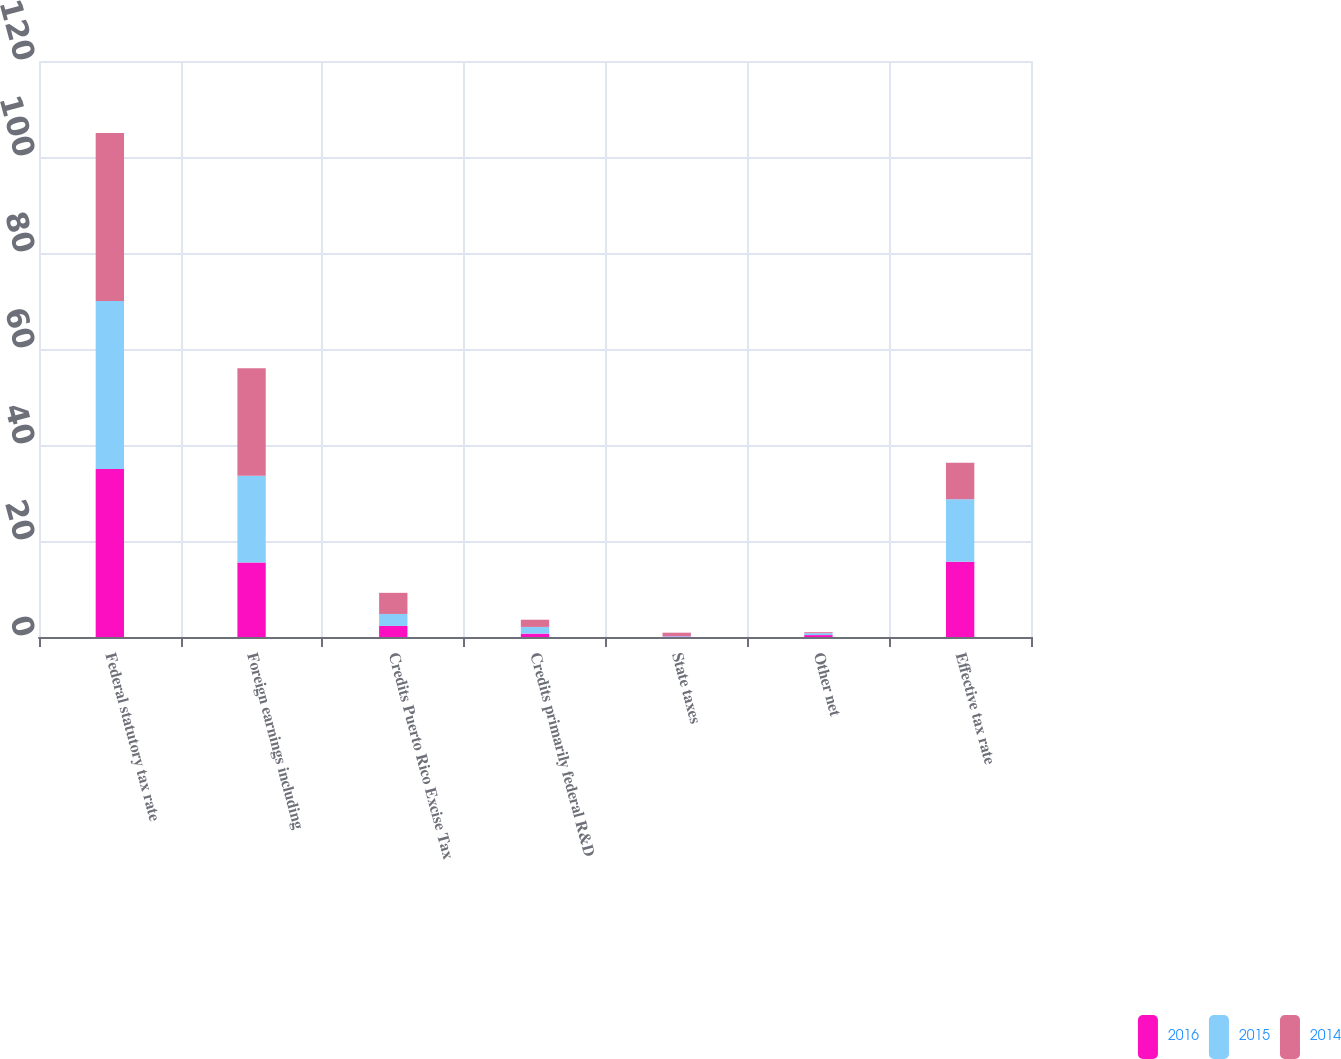Convert chart. <chart><loc_0><loc_0><loc_500><loc_500><stacked_bar_chart><ecel><fcel>Federal statutory tax rate<fcel>Foreign earnings including<fcel>Credits Puerto Rico Excise Tax<fcel>Credits primarily federal R&D<fcel>State taxes<fcel>Other net<fcel>Effective tax rate<nl><fcel>2016<fcel>35<fcel>15.5<fcel>2.3<fcel>0.7<fcel>0.1<fcel>0.4<fcel>15.7<nl><fcel>2015<fcel>35<fcel>18.1<fcel>2.5<fcel>1.4<fcel>0.1<fcel>0.4<fcel>13<nl><fcel>2014<fcel>35<fcel>22.4<fcel>4.4<fcel>1.5<fcel>0.7<fcel>0.2<fcel>7.6<nl></chart> 